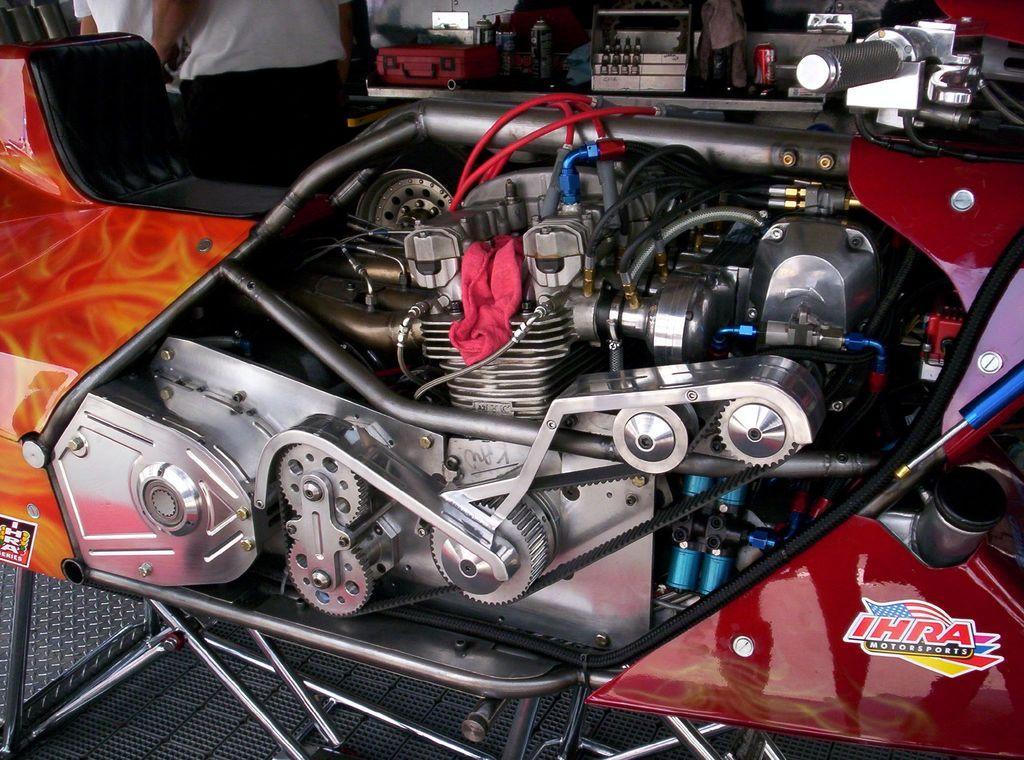Describe this image in one or two sentences. In this image we can see engine and other parts of the vehicle. At the top of the image we can see two people who are truncated. 